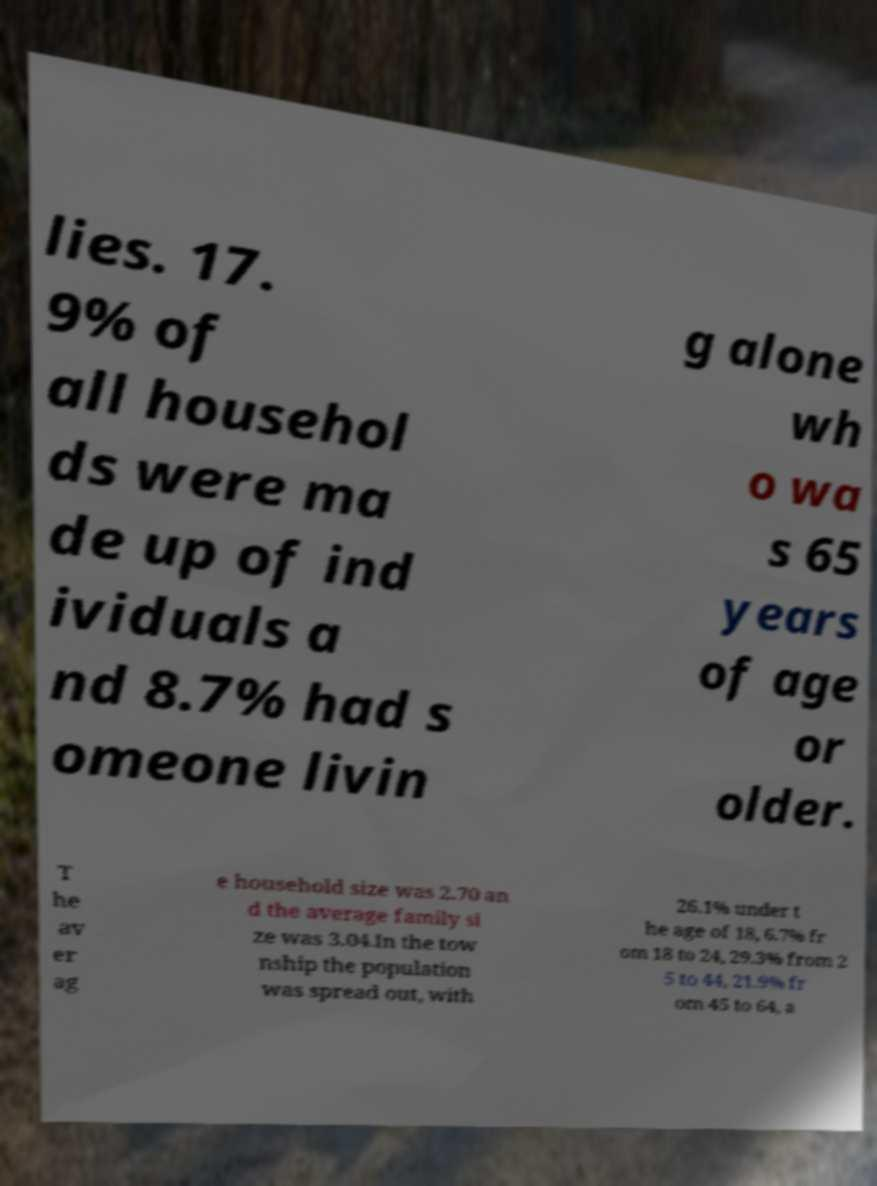Could you assist in decoding the text presented in this image and type it out clearly? lies. 17. 9% of all househol ds were ma de up of ind ividuals a nd 8.7% had s omeone livin g alone wh o wa s 65 years of age or older. T he av er ag e household size was 2.70 an d the average family si ze was 3.04.In the tow nship the population was spread out, with 26.1% under t he age of 18, 6.7% fr om 18 to 24, 29.3% from 2 5 to 44, 21.9% fr om 45 to 64, a 